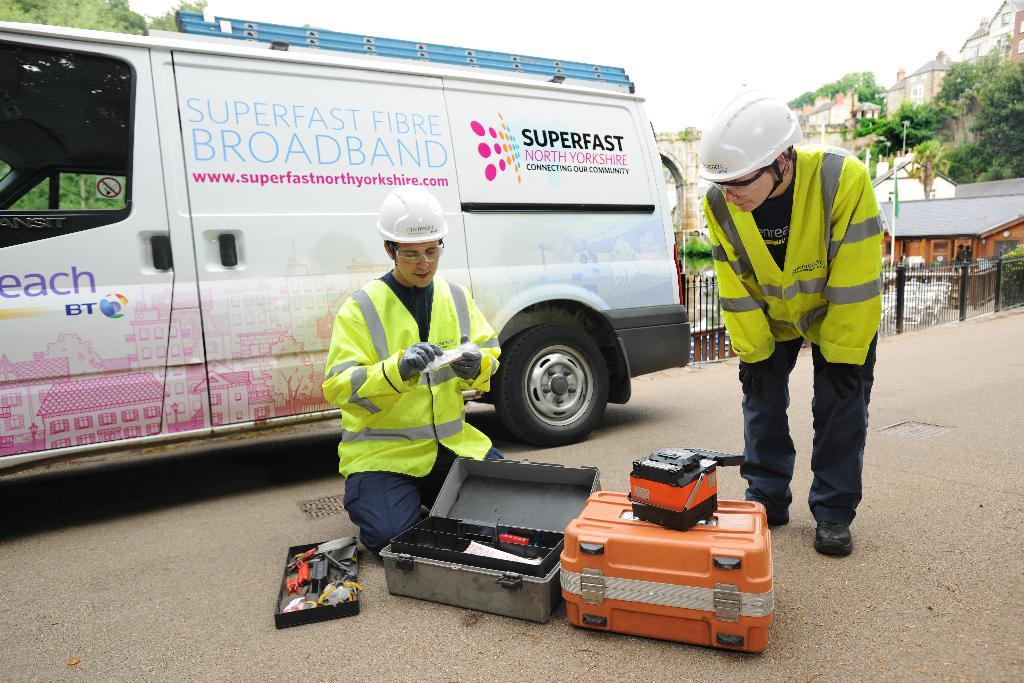How many people are in the image? There are 2 people in the image. What are the people wearing? The people are wearing white helmets, coats, and gloves. What objects can be seen in the image besides the people? There are 2 briefcases, a vehicle, a fence, buildings, and trees in the image. What type of whip is being used by the person in the image? There is no whip present in the image. How many hooks can be seen hanging from the fence in the image? There are no hooks visible on the fence in the image. 